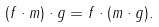Convert formula to latex. <formula><loc_0><loc_0><loc_500><loc_500>( f \cdot m ) \cdot g = f \cdot ( m \cdot g ) .</formula> 